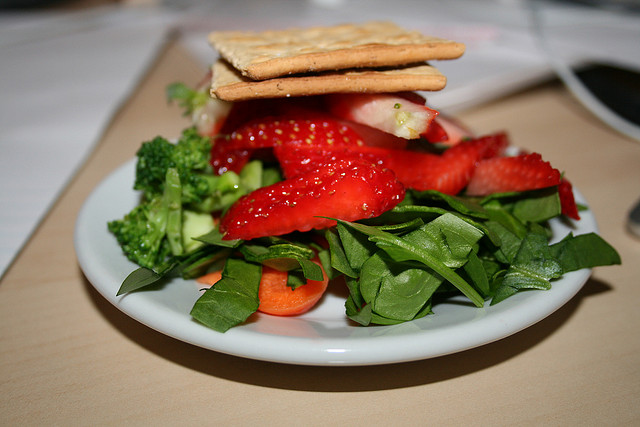<image>What are the spices used in the dish? It is not clear which spices were used in the dish. It could be spinach, time, peppers, salt, or garlic. What color is the dressing on the lettuce? There is no dressing on the lettuce. However, it can be clear, red or blue. What color is the dressing on the lettuce? The image doesn't show any dressing on the lettuce. What are the spices used in the dish? I am not sure what spices are used in the dish. It can be seen 'spinach', 'peppers', 'salt', 'garlic', or 'salt and pepper'. 